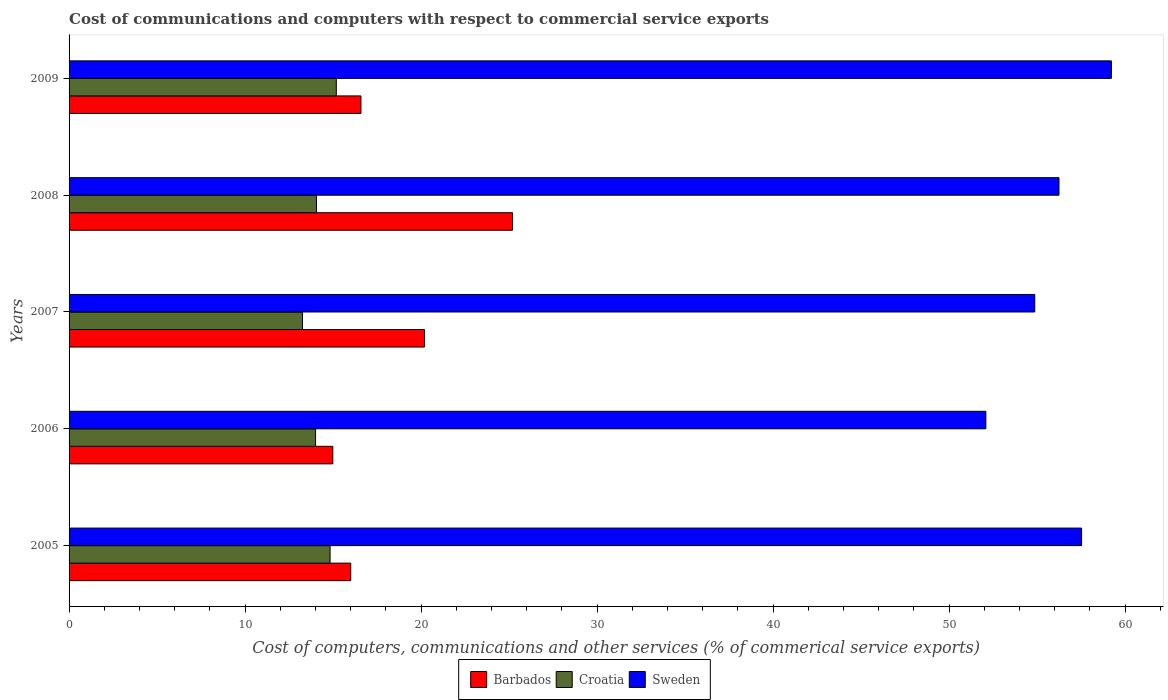How many different coloured bars are there?
Offer a very short reply. 3. Are the number of bars per tick equal to the number of legend labels?
Provide a short and direct response. Yes. Are the number of bars on each tick of the Y-axis equal?
Your response must be concise. Yes. How many bars are there on the 1st tick from the top?
Offer a very short reply. 3. How many bars are there on the 2nd tick from the bottom?
Keep it short and to the point. 3. In how many cases, is the number of bars for a given year not equal to the number of legend labels?
Offer a terse response. 0. What is the cost of communications and computers in Sweden in 2009?
Provide a short and direct response. 59.22. Across all years, what is the maximum cost of communications and computers in Croatia?
Make the answer very short. 15.18. Across all years, what is the minimum cost of communications and computers in Croatia?
Keep it short and to the point. 13.26. In which year was the cost of communications and computers in Sweden minimum?
Give a very brief answer. 2006. What is the total cost of communications and computers in Sweden in the graph?
Give a very brief answer. 279.95. What is the difference between the cost of communications and computers in Sweden in 2006 and that in 2009?
Your response must be concise. -7.13. What is the difference between the cost of communications and computers in Barbados in 2006 and the cost of communications and computers in Croatia in 2005?
Make the answer very short. 0.16. What is the average cost of communications and computers in Barbados per year?
Your response must be concise. 18.59. In the year 2007, what is the difference between the cost of communications and computers in Sweden and cost of communications and computers in Barbados?
Keep it short and to the point. 34.67. What is the ratio of the cost of communications and computers in Croatia in 2005 to that in 2009?
Ensure brevity in your answer.  0.98. Is the cost of communications and computers in Barbados in 2006 less than that in 2009?
Your response must be concise. Yes. Is the difference between the cost of communications and computers in Sweden in 2005 and 2007 greater than the difference between the cost of communications and computers in Barbados in 2005 and 2007?
Your answer should be compact. Yes. What is the difference between the highest and the second highest cost of communications and computers in Croatia?
Make the answer very short. 0.35. What is the difference between the highest and the lowest cost of communications and computers in Croatia?
Ensure brevity in your answer.  1.92. In how many years, is the cost of communications and computers in Barbados greater than the average cost of communications and computers in Barbados taken over all years?
Offer a very short reply. 2. What does the 2nd bar from the top in 2007 represents?
Provide a succinct answer. Croatia. What does the 1st bar from the bottom in 2005 represents?
Ensure brevity in your answer.  Barbados. Are all the bars in the graph horizontal?
Give a very brief answer. Yes. What is the difference between two consecutive major ticks on the X-axis?
Provide a succinct answer. 10. Where does the legend appear in the graph?
Your answer should be very brief. Bottom center. What is the title of the graph?
Provide a succinct answer. Cost of communications and computers with respect to commercial service exports. What is the label or title of the X-axis?
Keep it short and to the point. Cost of computers, communications and other services (% of commerical service exports). What is the Cost of computers, communications and other services (% of commerical service exports) in Barbados in 2005?
Make the answer very short. 16. What is the Cost of computers, communications and other services (% of commerical service exports) in Croatia in 2005?
Provide a succinct answer. 14.83. What is the Cost of computers, communications and other services (% of commerical service exports) of Sweden in 2005?
Your answer should be compact. 57.53. What is the Cost of computers, communications and other services (% of commerical service exports) of Barbados in 2006?
Make the answer very short. 14.99. What is the Cost of computers, communications and other services (% of commerical service exports) in Croatia in 2006?
Provide a short and direct response. 14. What is the Cost of computers, communications and other services (% of commerical service exports) of Sweden in 2006?
Keep it short and to the point. 52.09. What is the Cost of computers, communications and other services (% of commerical service exports) in Barbados in 2007?
Your answer should be compact. 20.2. What is the Cost of computers, communications and other services (% of commerical service exports) in Croatia in 2007?
Provide a short and direct response. 13.26. What is the Cost of computers, communications and other services (% of commerical service exports) of Sweden in 2007?
Your answer should be compact. 54.87. What is the Cost of computers, communications and other services (% of commerical service exports) of Barbados in 2008?
Offer a very short reply. 25.2. What is the Cost of computers, communications and other services (% of commerical service exports) of Croatia in 2008?
Your answer should be very brief. 14.06. What is the Cost of computers, communications and other services (% of commerical service exports) of Sweden in 2008?
Your answer should be very brief. 56.24. What is the Cost of computers, communications and other services (% of commerical service exports) of Barbados in 2009?
Offer a terse response. 16.58. What is the Cost of computers, communications and other services (% of commerical service exports) in Croatia in 2009?
Provide a succinct answer. 15.18. What is the Cost of computers, communications and other services (% of commerical service exports) in Sweden in 2009?
Offer a very short reply. 59.22. Across all years, what is the maximum Cost of computers, communications and other services (% of commerical service exports) in Barbados?
Your answer should be compact. 25.2. Across all years, what is the maximum Cost of computers, communications and other services (% of commerical service exports) in Croatia?
Your answer should be compact. 15.18. Across all years, what is the maximum Cost of computers, communications and other services (% of commerical service exports) in Sweden?
Your answer should be very brief. 59.22. Across all years, what is the minimum Cost of computers, communications and other services (% of commerical service exports) in Barbados?
Your answer should be compact. 14.99. Across all years, what is the minimum Cost of computers, communications and other services (% of commerical service exports) in Croatia?
Offer a terse response. 13.26. Across all years, what is the minimum Cost of computers, communications and other services (% of commerical service exports) of Sweden?
Ensure brevity in your answer.  52.09. What is the total Cost of computers, communications and other services (% of commerical service exports) in Barbados in the graph?
Your answer should be very brief. 92.96. What is the total Cost of computers, communications and other services (% of commerical service exports) in Croatia in the graph?
Give a very brief answer. 71.34. What is the total Cost of computers, communications and other services (% of commerical service exports) of Sweden in the graph?
Your answer should be very brief. 279.95. What is the difference between the Cost of computers, communications and other services (% of commerical service exports) in Barbados in 2005 and that in 2006?
Provide a short and direct response. 1.02. What is the difference between the Cost of computers, communications and other services (% of commerical service exports) of Croatia in 2005 and that in 2006?
Give a very brief answer. 0.83. What is the difference between the Cost of computers, communications and other services (% of commerical service exports) in Sweden in 2005 and that in 2006?
Make the answer very short. 5.44. What is the difference between the Cost of computers, communications and other services (% of commerical service exports) of Barbados in 2005 and that in 2007?
Your answer should be compact. -4.19. What is the difference between the Cost of computers, communications and other services (% of commerical service exports) of Croatia in 2005 and that in 2007?
Your answer should be compact. 1.57. What is the difference between the Cost of computers, communications and other services (% of commerical service exports) in Sweden in 2005 and that in 2007?
Provide a short and direct response. 2.66. What is the difference between the Cost of computers, communications and other services (% of commerical service exports) of Barbados in 2005 and that in 2008?
Provide a short and direct response. -9.19. What is the difference between the Cost of computers, communications and other services (% of commerical service exports) of Croatia in 2005 and that in 2008?
Make the answer very short. 0.77. What is the difference between the Cost of computers, communications and other services (% of commerical service exports) in Sweden in 2005 and that in 2008?
Your answer should be compact. 1.28. What is the difference between the Cost of computers, communications and other services (% of commerical service exports) in Barbados in 2005 and that in 2009?
Make the answer very short. -0.58. What is the difference between the Cost of computers, communications and other services (% of commerical service exports) of Croatia in 2005 and that in 2009?
Offer a very short reply. -0.35. What is the difference between the Cost of computers, communications and other services (% of commerical service exports) in Sweden in 2005 and that in 2009?
Offer a very short reply. -1.69. What is the difference between the Cost of computers, communications and other services (% of commerical service exports) of Barbados in 2006 and that in 2007?
Your answer should be compact. -5.21. What is the difference between the Cost of computers, communications and other services (% of commerical service exports) in Croatia in 2006 and that in 2007?
Provide a short and direct response. 0.74. What is the difference between the Cost of computers, communications and other services (% of commerical service exports) of Sweden in 2006 and that in 2007?
Provide a short and direct response. -2.78. What is the difference between the Cost of computers, communications and other services (% of commerical service exports) in Barbados in 2006 and that in 2008?
Keep it short and to the point. -10.21. What is the difference between the Cost of computers, communications and other services (% of commerical service exports) in Croatia in 2006 and that in 2008?
Ensure brevity in your answer.  -0.05. What is the difference between the Cost of computers, communications and other services (% of commerical service exports) of Sweden in 2006 and that in 2008?
Keep it short and to the point. -4.15. What is the difference between the Cost of computers, communications and other services (% of commerical service exports) in Barbados in 2006 and that in 2009?
Your response must be concise. -1.6. What is the difference between the Cost of computers, communications and other services (% of commerical service exports) of Croatia in 2006 and that in 2009?
Offer a terse response. -1.18. What is the difference between the Cost of computers, communications and other services (% of commerical service exports) in Sweden in 2006 and that in 2009?
Your answer should be compact. -7.13. What is the difference between the Cost of computers, communications and other services (% of commerical service exports) of Barbados in 2007 and that in 2008?
Make the answer very short. -5. What is the difference between the Cost of computers, communications and other services (% of commerical service exports) of Croatia in 2007 and that in 2008?
Provide a succinct answer. -0.79. What is the difference between the Cost of computers, communications and other services (% of commerical service exports) in Sweden in 2007 and that in 2008?
Offer a very short reply. -1.38. What is the difference between the Cost of computers, communications and other services (% of commerical service exports) of Barbados in 2007 and that in 2009?
Make the answer very short. 3.61. What is the difference between the Cost of computers, communications and other services (% of commerical service exports) of Croatia in 2007 and that in 2009?
Ensure brevity in your answer.  -1.92. What is the difference between the Cost of computers, communications and other services (% of commerical service exports) of Sweden in 2007 and that in 2009?
Your answer should be very brief. -4.35. What is the difference between the Cost of computers, communications and other services (% of commerical service exports) of Barbados in 2008 and that in 2009?
Provide a short and direct response. 8.61. What is the difference between the Cost of computers, communications and other services (% of commerical service exports) in Croatia in 2008 and that in 2009?
Ensure brevity in your answer.  -1.13. What is the difference between the Cost of computers, communications and other services (% of commerical service exports) of Sweden in 2008 and that in 2009?
Your answer should be very brief. -2.98. What is the difference between the Cost of computers, communications and other services (% of commerical service exports) of Barbados in 2005 and the Cost of computers, communications and other services (% of commerical service exports) of Croatia in 2006?
Keep it short and to the point. 2. What is the difference between the Cost of computers, communications and other services (% of commerical service exports) of Barbados in 2005 and the Cost of computers, communications and other services (% of commerical service exports) of Sweden in 2006?
Offer a very short reply. -36.09. What is the difference between the Cost of computers, communications and other services (% of commerical service exports) of Croatia in 2005 and the Cost of computers, communications and other services (% of commerical service exports) of Sweden in 2006?
Give a very brief answer. -37.26. What is the difference between the Cost of computers, communications and other services (% of commerical service exports) in Barbados in 2005 and the Cost of computers, communications and other services (% of commerical service exports) in Croatia in 2007?
Give a very brief answer. 2.74. What is the difference between the Cost of computers, communications and other services (% of commerical service exports) in Barbados in 2005 and the Cost of computers, communications and other services (% of commerical service exports) in Sweden in 2007?
Offer a very short reply. -38.87. What is the difference between the Cost of computers, communications and other services (% of commerical service exports) in Croatia in 2005 and the Cost of computers, communications and other services (% of commerical service exports) in Sweden in 2007?
Your answer should be compact. -40.04. What is the difference between the Cost of computers, communications and other services (% of commerical service exports) of Barbados in 2005 and the Cost of computers, communications and other services (% of commerical service exports) of Croatia in 2008?
Your answer should be compact. 1.95. What is the difference between the Cost of computers, communications and other services (% of commerical service exports) of Barbados in 2005 and the Cost of computers, communications and other services (% of commerical service exports) of Sweden in 2008?
Make the answer very short. -40.24. What is the difference between the Cost of computers, communications and other services (% of commerical service exports) in Croatia in 2005 and the Cost of computers, communications and other services (% of commerical service exports) in Sweden in 2008?
Your answer should be very brief. -41.41. What is the difference between the Cost of computers, communications and other services (% of commerical service exports) in Barbados in 2005 and the Cost of computers, communications and other services (% of commerical service exports) in Croatia in 2009?
Provide a succinct answer. 0.82. What is the difference between the Cost of computers, communications and other services (% of commerical service exports) of Barbados in 2005 and the Cost of computers, communications and other services (% of commerical service exports) of Sweden in 2009?
Your answer should be compact. -43.22. What is the difference between the Cost of computers, communications and other services (% of commerical service exports) in Croatia in 2005 and the Cost of computers, communications and other services (% of commerical service exports) in Sweden in 2009?
Your answer should be very brief. -44.39. What is the difference between the Cost of computers, communications and other services (% of commerical service exports) in Barbados in 2006 and the Cost of computers, communications and other services (% of commerical service exports) in Croatia in 2007?
Your answer should be very brief. 1.72. What is the difference between the Cost of computers, communications and other services (% of commerical service exports) in Barbados in 2006 and the Cost of computers, communications and other services (% of commerical service exports) in Sweden in 2007?
Offer a very short reply. -39.88. What is the difference between the Cost of computers, communications and other services (% of commerical service exports) of Croatia in 2006 and the Cost of computers, communications and other services (% of commerical service exports) of Sweden in 2007?
Offer a terse response. -40.86. What is the difference between the Cost of computers, communications and other services (% of commerical service exports) in Barbados in 2006 and the Cost of computers, communications and other services (% of commerical service exports) in Croatia in 2008?
Your response must be concise. 0.93. What is the difference between the Cost of computers, communications and other services (% of commerical service exports) of Barbados in 2006 and the Cost of computers, communications and other services (% of commerical service exports) of Sweden in 2008?
Ensure brevity in your answer.  -41.26. What is the difference between the Cost of computers, communications and other services (% of commerical service exports) in Croatia in 2006 and the Cost of computers, communications and other services (% of commerical service exports) in Sweden in 2008?
Offer a very short reply. -42.24. What is the difference between the Cost of computers, communications and other services (% of commerical service exports) in Barbados in 2006 and the Cost of computers, communications and other services (% of commerical service exports) in Croatia in 2009?
Give a very brief answer. -0.2. What is the difference between the Cost of computers, communications and other services (% of commerical service exports) in Barbados in 2006 and the Cost of computers, communications and other services (% of commerical service exports) in Sweden in 2009?
Make the answer very short. -44.24. What is the difference between the Cost of computers, communications and other services (% of commerical service exports) in Croatia in 2006 and the Cost of computers, communications and other services (% of commerical service exports) in Sweden in 2009?
Provide a succinct answer. -45.22. What is the difference between the Cost of computers, communications and other services (% of commerical service exports) of Barbados in 2007 and the Cost of computers, communications and other services (% of commerical service exports) of Croatia in 2008?
Your response must be concise. 6.14. What is the difference between the Cost of computers, communications and other services (% of commerical service exports) of Barbados in 2007 and the Cost of computers, communications and other services (% of commerical service exports) of Sweden in 2008?
Provide a succinct answer. -36.05. What is the difference between the Cost of computers, communications and other services (% of commerical service exports) of Croatia in 2007 and the Cost of computers, communications and other services (% of commerical service exports) of Sweden in 2008?
Your response must be concise. -42.98. What is the difference between the Cost of computers, communications and other services (% of commerical service exports) in Barbados in 2007 and the Cost of computers, communications and other services (% of commerical service exports) in Croatia in 2009?
Provide a succinct answer. 5.01. What is the difference between the Cost of computers, communications and other services (% of commerical service exports) of Barbados in 2007 and the Cost of computers, communications and other services (% of commerical service exports) of Sweden in 2009?
Offer a terse response. -39.03. What is the difference between the Cost of computers, communications and other services (% of commerical service exports) of Croatia in 2007 and the Cost of computers, communications and other services (% of commerical service exports) of Sweden in 2009?
Ensure brevity in your answer.  -45.96. What is the difference between the Cost of computers, communications and other services (% of commerical service exports) in Barbados in 2008 and the Cost of computers, communications and other services (% of commerical service exports) in Croatia in 2009?
Keep it short and to the point. 10.01. What is the difference between the Cost of computers, communications and other services (% of commerical service exports) in Barbados in 2008 and the Cost of computers, communications and other services (% of commerical service exports) in Sweden in 2009?
Give a very brief answer. -34.03. What is the difference between the Cost of computers, communications and other services (% of commerical service exports) of Croatia in 2008 and the Cost of computers, communications and other services (% of commerical service exports) of Sweden in 2009?
Provide a short and direct response. -45.16. What is the average Cost of computers, communications and other services (% of commerical service exports) of Barbados per year?
Your response must be concise. 18.59. What is the average Cost of computers, communications and other services (% of commerical service exports) of Croatia per year?
Offer a terse response. 14.27. What is the average Cost of computers, communications and other services (% of commerical service exports) of Sweden per year?
Your response must be concise. 55.99. In the year 2005, what is the difference between the Cost of computers, communications and other services (% of commerical service exports) in Barbados and Cost of computers, communications and other services (% of commerical service exports) in Croatia?
Your response must be concise. 1.17. In the year 2005, what is the difference between the Cost of computers, communications and other services (% of commerical service exports) in Barbados and Cost of computers, communications and other services (% of commerical service exports) in Sweden?
Give a very brief answer. -41.53. In the year 2005, what is the difference between the Cost of computers, communications and other services (% of commerical service exports) of Croatia and Cost of computers, communications and other services (% of commerical service exports) of Sweden?
Offer a very short reply. -42.7. In the year 2006, what is the difference between the Cost of computers, communications and other services (% of commerical service exports) in Barbados and Cost of computers, communications and other services (% of commerical service exports) in Croatia?
Keep it short and to the point. 0.98. In the year 2006, what is the difference between the Cost of computers, communications and other services (% of commerical service exports) of Barbados and Cost of computers, communications and other services (% of commerical service exports) of Sweden?
Provide a succinct answer. -37.1. In the year 2006, what is the difference between the Cost of computers, communications and other services (% of commerical service exports) of Croatia and Cost of computers, communications and other services (% of commerical service exports) of Sweden?
Offer a very short reply. -38.09. In the year 2007, what is the difference between the Cost of computers, communications and other services (% of commerical service exports) in Barbados and Cost of computers, communications and other services (% of commerical service exports) in Croatia?
Make the answer very short. 6.93. In the year 2007, what is the difference between the Cost of computers, communications and other services (% of commerical service exports) in Barbados and Cost of computers, communications and other services (% of commerical service exports) in Sweden?
Your answer should be very brief. -34.67. In the year 2007, what is the difference between the Cost of computers, communications and other services (% of commerical service exports) in Croatia and Cost of computers, communications and other services (% of commerical service exports) in Sweden?
Keep it short and to the point. -41.6. In the year 2008, what is the difference between the Cost of computers, communications and other services (% of commerical service exports) in Barbados and Cost of computers, communications and other services (% of commerical service exports) in Croatia?
Provide a short and direct response. 11.14. In the year 2008, what is the difference between the Cost of computers, communications and other services (% of commerical service exports) of Barbados and Cost of computers, communications and other services (% of commerical service exports) of Sweden?
Ensure brevity in your answer.  -31.05. In the year 2008, what is the difference between the Cost of computers, communications and other services (% of commerical service exports) in Croatia and Cost of computers, communications and other services (% of commerical service exports) in Sweden?
Your response must be concise. -42.19. In the year 2009, what is the difference between the Cost of computers, communications and other services (% of commerical service exports) of Barbados and Cost of computers, communications and other services (% of commerical service exports) of Croatia?
Offer a terse response. 1.4. In the year 2009, what is the difference between the Cost of computers, communications and other services (% of commerical service exports) in Barbados and Cost of computers, communications and other services (% of commerical service exports) in Sweden?
Offer a terse response. -42.64. In the year 2009, what is the difference between the Cost of computers, communications and other services (% of commerical service exports) of Croatia and Cost of computers, communications and other services (% of commerical service exports) of Sweden?
Your response must be concise. -44.04. What is the ratio of the Cost of computers, communications and other services (% of commerical service exports) in Barbados in 2005 to that in 2006?
Ensure brevity in your answer.  1.07. What is the ratio of the Cost of computers, communications and other services (% of commerical service exports) of Croatia in 2005 to that in 2006?
Provide a short and direct response. 1.06. What is the ratio of the Cost of computers, communications and other services (% of commerical service exports) of Sweden in 2005 to that in 2006?
Provide a short and direct response. 1.1. What is the ratio of the Cost of computers, communications and other services (% of commerical service exports) of Barbados in 2005 to that in 2007?
Make the answer very short. 0.79. What is the ratio of the Cost of computers, communications and other services (% of commerical service exports) in Croatia in 2005 to that in 2007?
Your answer should be very brief. 1.12. What is the ratio of the Cost of computers, communications and other services (% of commerical service exports) of Sweden in 2005 to that in 2007?
Provide a short and direct response. 1.05. What is the ratio of the Cost of computers, communications and other services (% of commerical service exports) of Barbados in 2005 to that in 2008?
Your response must be concise. 0.64. What is the ratio of the Cost of computers, communications and other services (% of commerical service exports) in Croatia in 2005 to that in 2008?
Keep it short and to the point. 1.05. What is the ratio of the Cost of computers, communications and other services (% of commerical service exports) of Sweden in 2005 to that in 2008?
Keep it short and to the point. 1.02. What is the ratio of the Cost of computers, communications and other services (% of commerical service exports) in Barbados in 2005 to that in 2009?
Provide a succinct answer. 0.96. What is the ratio of the Cost of computers, communications and other services (% of commerical service exports) of Croatia in 2005 to that in 2009?
Provide a succinct answer. 0.98. What is the ratio of the Cost of computers, communications and other services (% of commerical service exports) in Sweden in 2005 to that in 2009?
Offer a very short reply. 0.97. What is the ratio of the Cost of computers, communications and other services (% of commerical service exports) of Barbados in 2006 to that in 2007?
Keep it short and to the point. 0.74. What is the ratio of the Cost of computers, communications and other services (% of commerical service exports) in Croatia in 2006 to that in 2007?
Offer a very short reply. 1.06. What is the ratio of the Cost of computers, communications and other services (% of commerical service exports) of Sweden in 2006 to that in 2007?
Offer a terse response. 0.95. What is the ratio of the Cost of computers, communications and other services (% of commerical service exports) of Barbados in 2006 to that in 2008?
Make the answer very short. 0.59. What is the ratio of the Cost of computers, communications and other services (% of commerical service exports) in Sweden in 2006 to that in 2008?
Ensure brevity in your answer.  0.93. What is the ratio of the Cost of computers, communications and other services (% of commerical service exports) of Barbados in 2006 to that in 2009?
Ensure brevity in your answer.  0.9. What is the ratio of the Cost of computers, communications and other services (% of commerical service exports) in Croatia in 2006 to that in 2009?
Keep it short and to the point. 0.92. What is the ratio of the Cost of computers, communications and other services (% of commerical service exports) in Sweden in 2006 to that in 2009?
Offer a terse response. 0.88. What is the ratio of the Cost of computers, communications and other services (% of commerical service exports) of Barbados in 2007 to that in 2008?
Provide a short and direct response. 0.8. What is the ratio of the Cost of computers, communications and other services (% of commerical service exports) in Croatia in 2007 to that in 2008?
Offer a very short reply. 0.94. What is the ratio of the Cost of computers, communications and other services (% of commerical service exports) in Sweden in 2007 to that in 2008?
Ensure brevity in your answer.  0.98. What is the ratio of the Cost of computers, communications and other services (% of commerical service exports) of Barbados in 2007 to that in 2009?
Provide a short and direct response. 1.22. What is the ratio of the Cost of computers, communications and other services (% of commerical service exports) of Croatia in 2007 to that in 2009?
Offer a terse response. 0.87. What is the ratio of the Cost of computers, communications and other services (% of commerical service exports) of Sweden in 2007 to that in 2009?
Your response must be concise. 0.93. What is the ratio of the Cost of computers, communications and other services (% of commerical service exports) in Barbados in 2008 to that in 2009?
Your answer should be compact. 1.52. What is the ratio of the Cost of computers, communications and other services (% of commerical service exports) of Croatia in 2008 to that in 2009?
Keep it short and to the point. 0.93. What is the ratio of the Cost of computers, communications and other services (% of commerical service exports) in Sweden in 2008 to that in 2009?
Provide a succinct answer. 0.95. What is the difference between the highest and the second highest Cost of computers, communications and other services (% of commerical service exports) in Barbados?
Keep it short and to the point. 5. What is the difference between the highest and the second highest Cost of computers, communications and other services (% of commerical service exports) in Croatia?
Offer a very short reply. 0.35. What is the difference between the highest and the second highest Cost of computers, communications and other services (% of commerical service exports) of Sweden?
Provide a succinct answer. 1.69. What is the difference between the highest and the lowest Cost of computers, communications and other services (% of commerical service exports) of Barbados?
Keep it short and to the point. 10.21. What is the difference between the highest and the lowest Cost of computers, communications and other services (% of commerical service exports) of Croatia?
Keep it short and to the point. 1.92. What is the difference between the highest and the lowest Cost of computers, communications and other services (% of commerical service exports) of Sweden?
Keep it short and to the point. 7.13. 